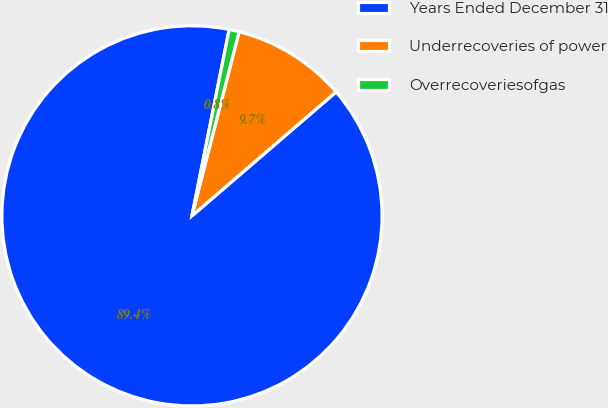<chart> <loc_0><loc_0><loc_500><loc_500><pie_chart><fcel>Years Ended December 31<fcel>Underrecoveries of power<fcel>Overrecoveriesofgas<nl><fcel>89.45%<fcel>9.71%<fcel>0.85%<nl></chart> 